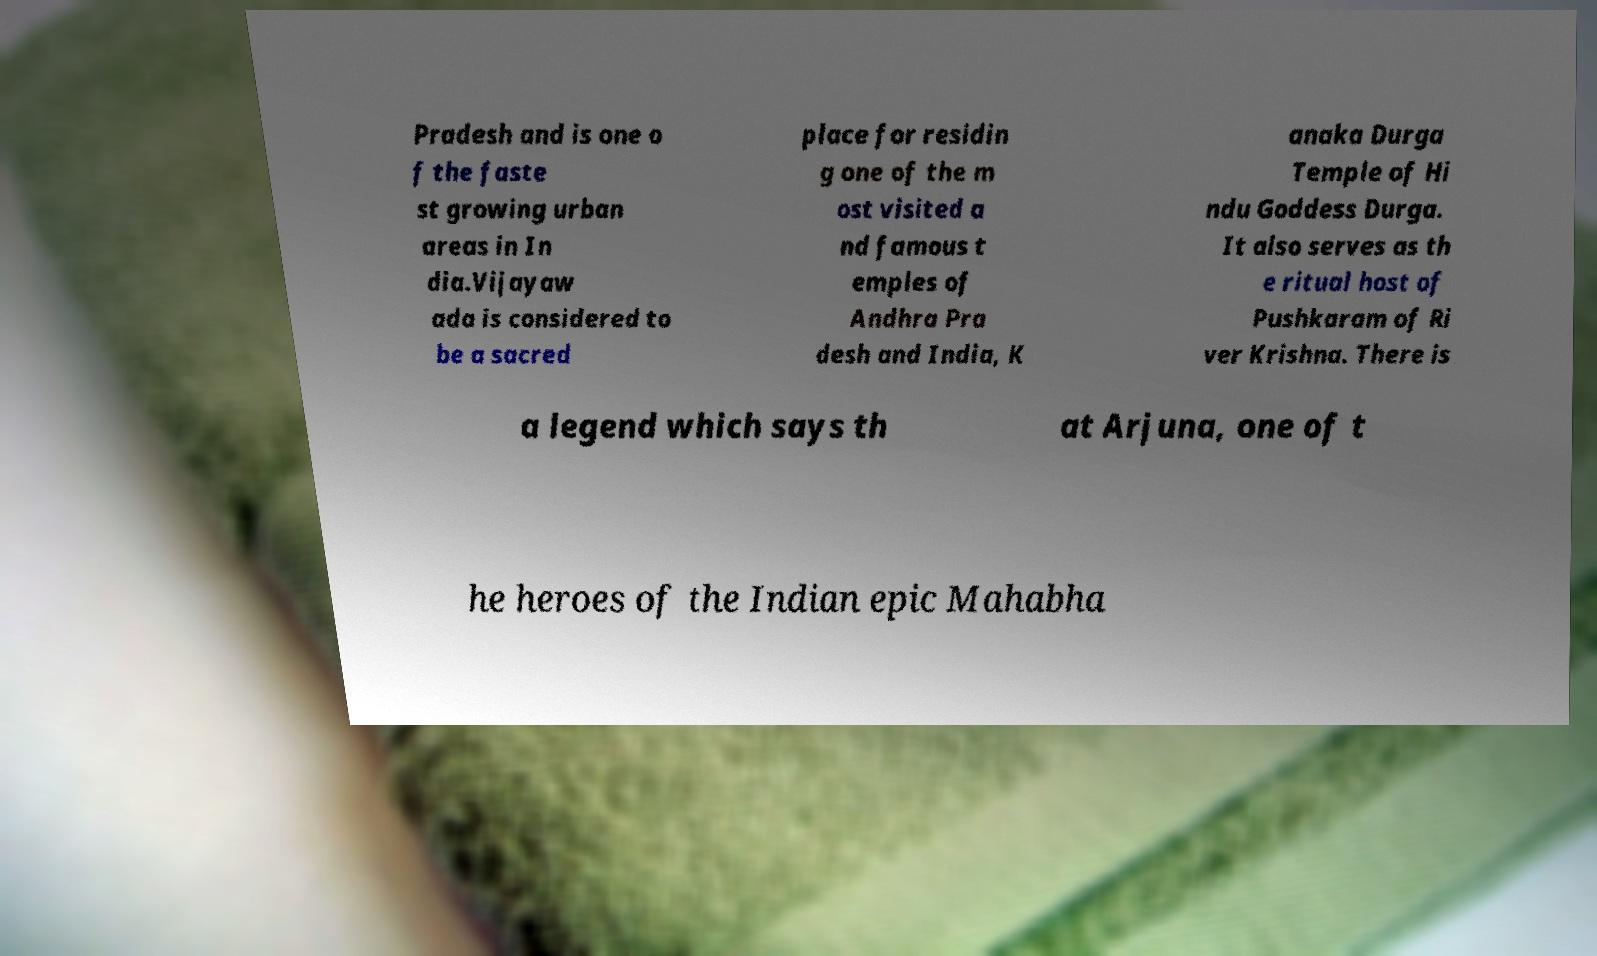I need the written content from this picture converted into text. Can you do that? Pradesh and is one o f the faste st growing urban areas in In dia.Vijayaw ada is considered to be a sacred place for residin g one of the m ost visited a nd famous t emples of Andhra Pra desh and India, K anaka Durga Temple of Hi ndu Goddess Durga. It also serves as th e ritual host of Pushkaram of Ri ver Krishna. There is a legend which says th at Arjuna, one of t he heroes of the Indian epic Mahabha 